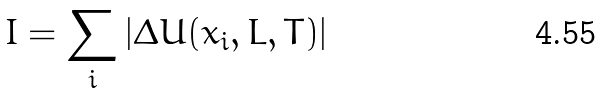<formula> <loc_0><loc_0><loc_500><loc_500>I = \sum _ { i } \left | \Delta U ( x _ { i } , L , T ) \right |</formula> 